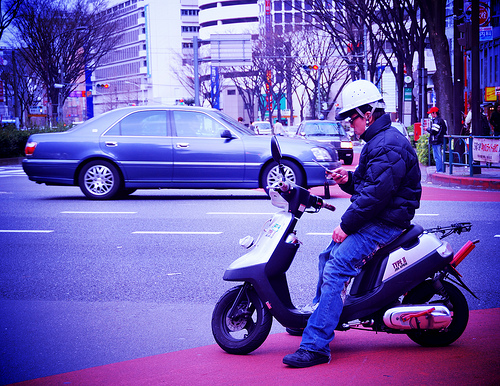Describe the safety gear the scooter rider is using. The rider is wearing a safety helmet, which is essential for protection while riding. They also seem to be dressed in a jacket, potentially providing some level of protection against the elements and in the case of an accident. 